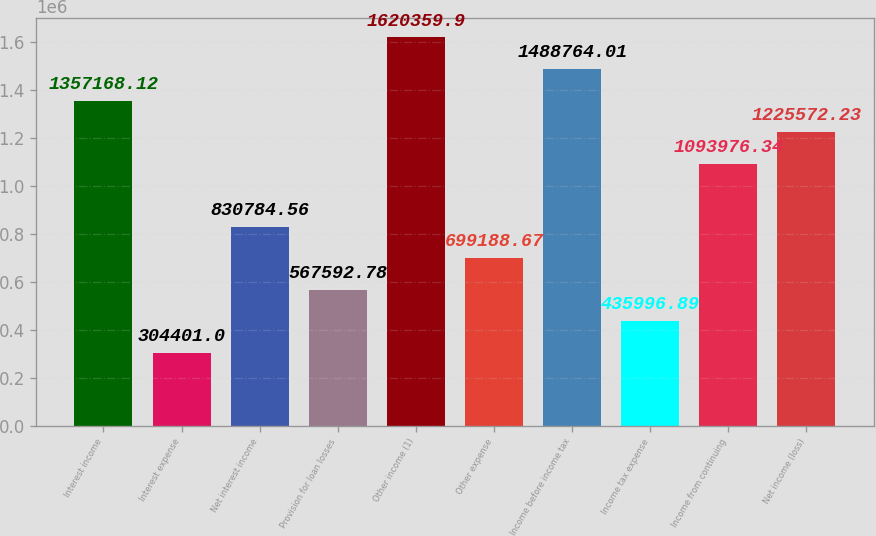<chart> <loc_0><loc_0><loc_500><loc_500><bar_chart><fcel>Interest income<fcel>Interest expense<fcel>Net interest income<fcel>Provision for loan losses<fcel>Other income (1)<fcel>Other expense<fcel>Income before income tax<fcel>Income tax expense<fcel>Income from continuing<fcel>Net income (loss)<nl><fcel>1.35717e+06<fcel>304401<fcel>830785<fcel>567593<fcel>1.62036e+06<fcel>699189<fcel>1.48876e+06<fcel>435997<fcel>1.09398e+06<fcel>1.22557e+06<nl></chart> 